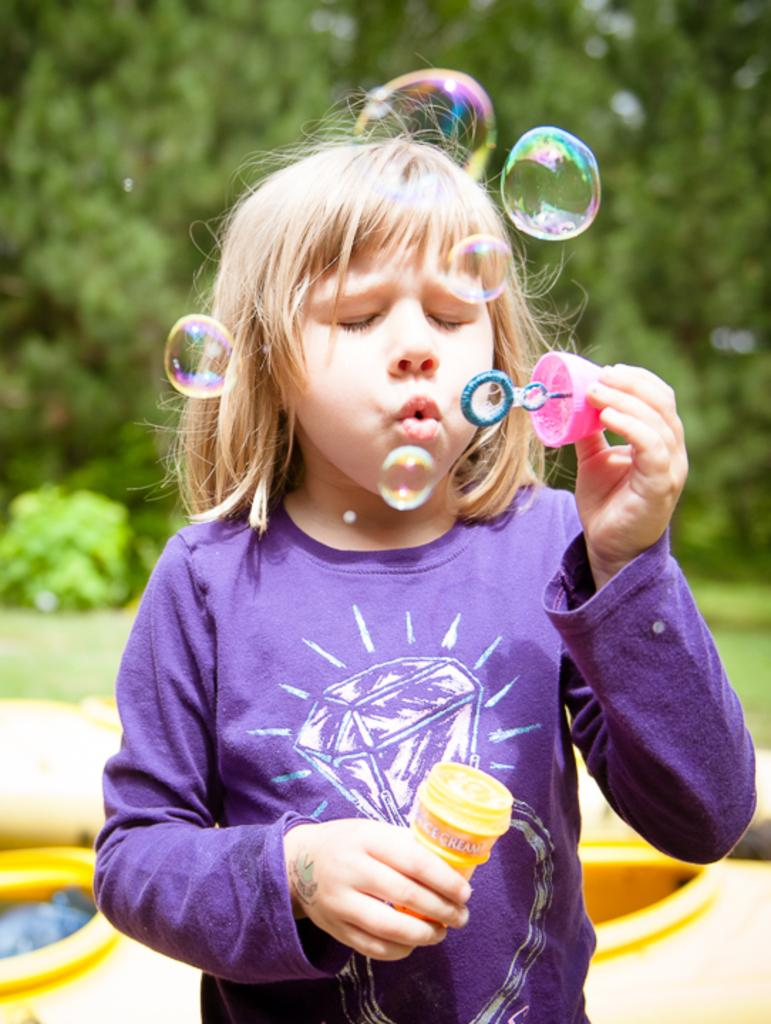Who is the main subject in the image? There is a girl in the image. What is the girl doing in the image? The girl is playing with water bubbles. What type of natural environment is visible in the image? There is grass in the image, and trees can be seen in the background. What type of oatmeal is being served on the hill in the image? There is no hill or oatmeal present in the image. The girl is playing with water bubbles in a grassy area with trees in the background. 